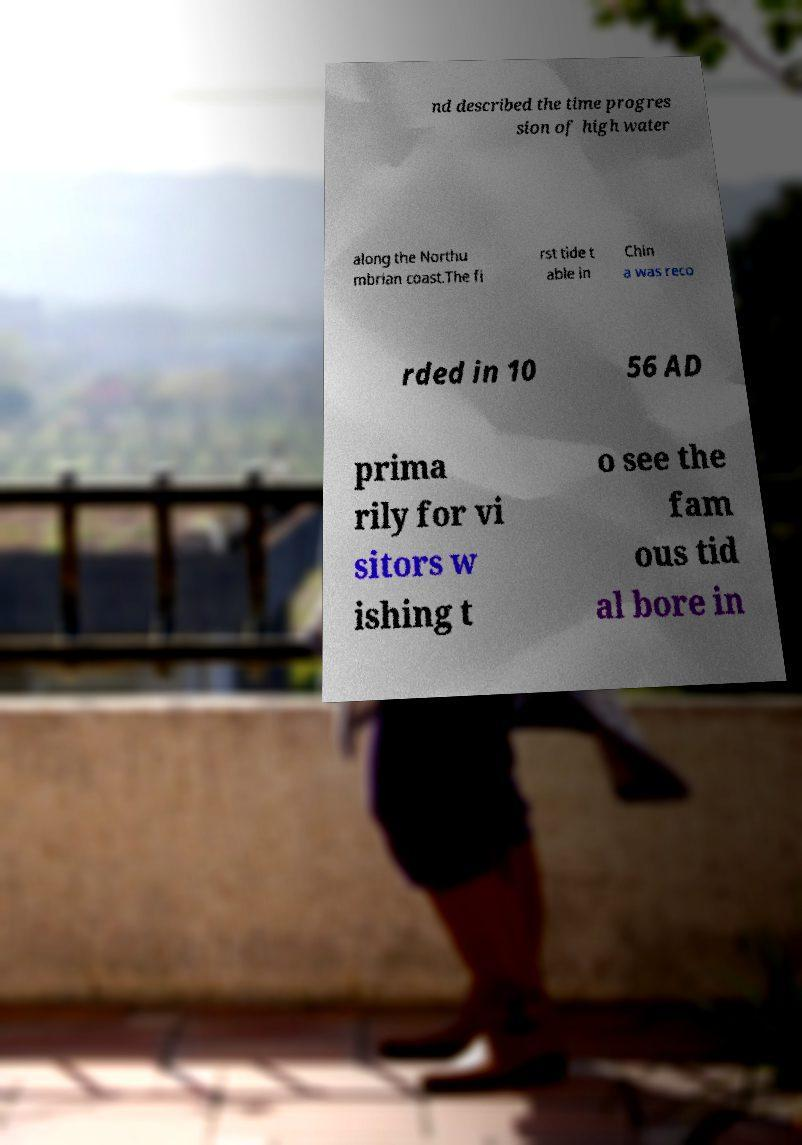Can you accurately transcribe the text from the provided image for me? nd described the time progres sion of high water along the Northu mbrian coast.The fi rst tide t able in Chin a was reco rded in 10 56 AD prima rily for vi sitors w ishing t o see the fam ous tid al bore in 